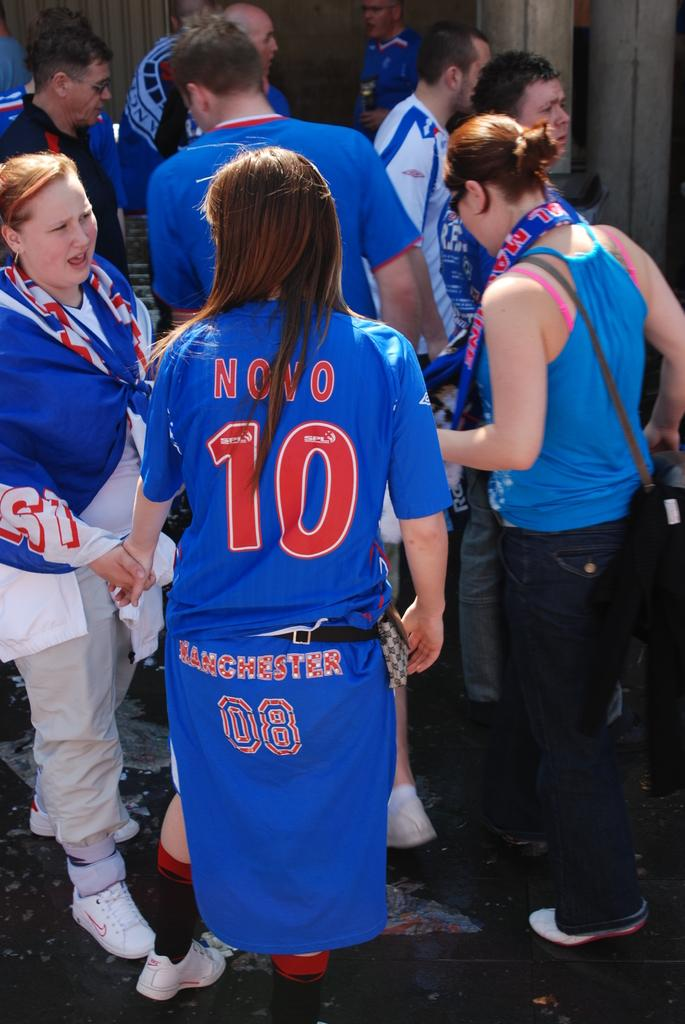<image>
Share a concise interpretation of the image provided. The back of a woman wearing a blue shirt with the words Novo and the number 10 